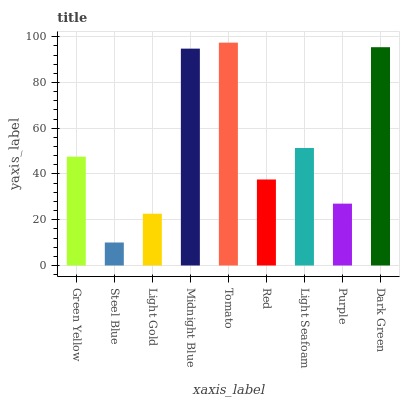Is Light Gold the minimum?
Answer yes or no. No. Is Light Gold the maximum?
Answer yes or no. No. Is Light Gold greater than Steel Blue?
Answer yes or no. Yes. Is Steel Blue less than Light Gold?
Answer yes or no. Yes. Is Steel Blue greater than Light Gold?
Answer yes or no. No. Is Light Gold less than Steel Blue?
Answer yes or no. No. Is Green Yellow the high median?
Answer yes or no. Yes. Is Green Yellow the low median?
Answer yes or no. Yes. Is Steel Blue the high median?
Answer yes or no. No. Is Light Seafoam the low median?
Answer yes or no. No. 